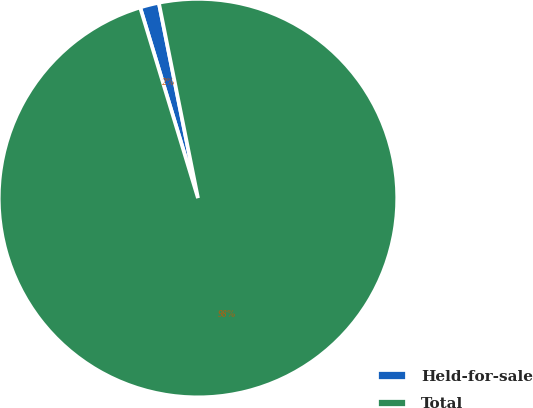Convert chart. <chart><loc_0><loc_0><loc_500><loc_500><pie_chart><fcel>Held-for-sale<fcel>Total<nl><fcel>1.54%<fcel>98.46%<nl></chart> 